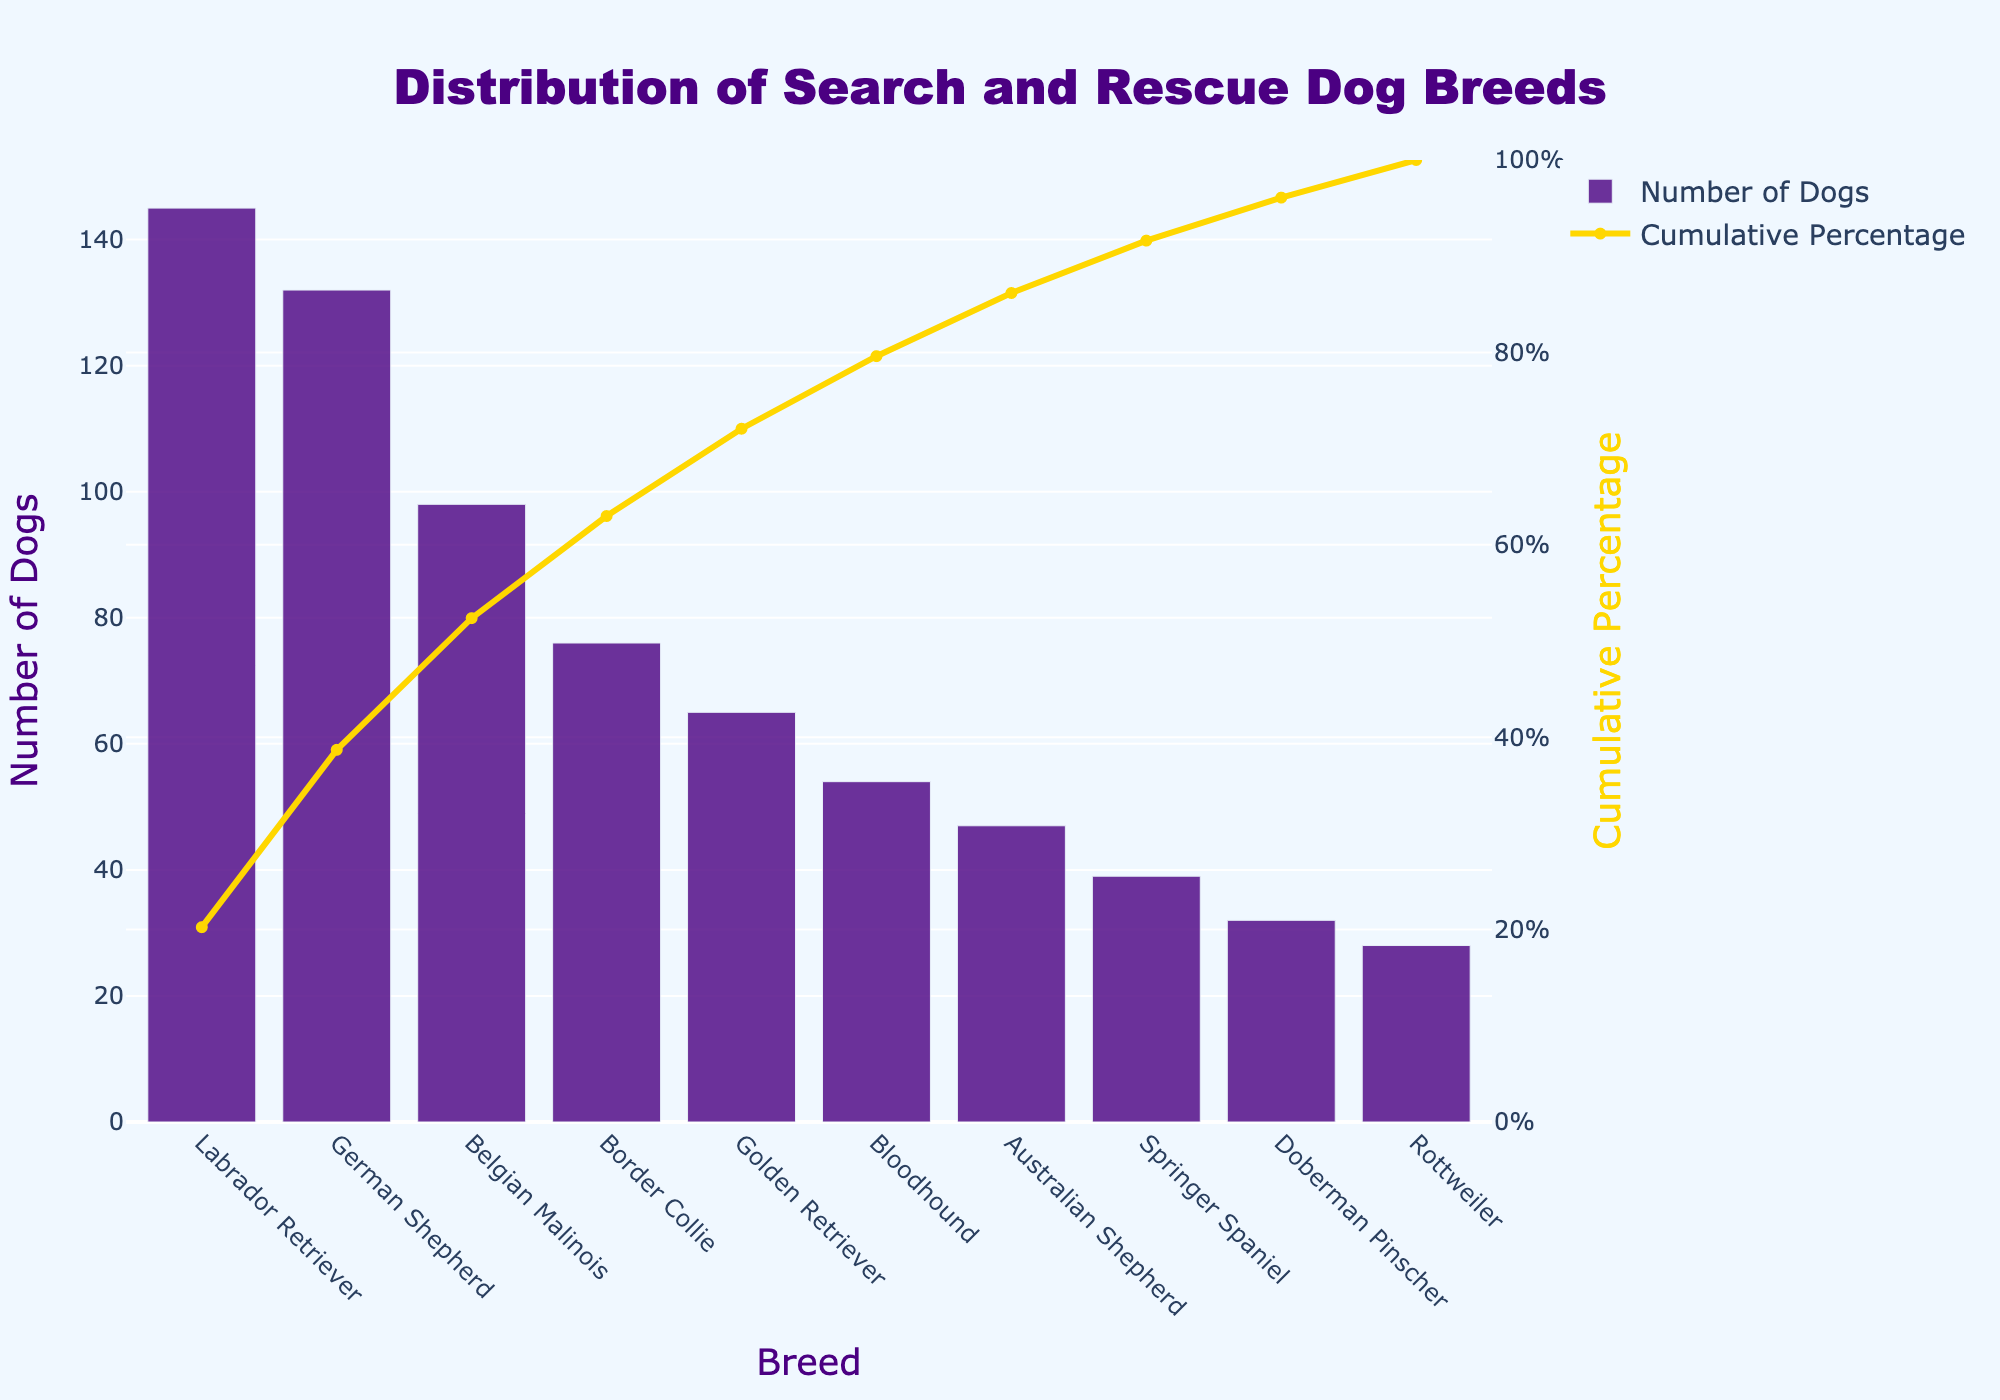What's the title of the chart? The title of the chart is typically located at the top and provides a brief description of the chart's content. Here, it is clearly stated at the top of the figure.
Answer: Distribution of Search and Rescue Dog Breeds How many breeds are displayed in the chart? To determine this, count the number of unique bars or categories on the x-axis. Each bar represents a different breed.
Answer: 10 Which breed has the highest number of search and rescue dogs? Look at the bar that is the tallest, which is indicative of the highest value on the y-axis.
Answer: Labrador Retriever What is the cumulative percentage for the German Shepherd breed? Locate the bar for German Shepherd and find its corresponding point on the cumulative percentage line, then extract the value from the y2-axis on the right.
Answer: Approximately 44% Name the top three breeds by the number of search and rescue dogs. Identify the first three bars from left to right, which correspond to the breeds with the highest values.
Answer: Labrador Retriever, German Shepherd, Belgian Malinois What percentage of the total search and rescue dogs does the top three breeds constitute? Sum the number of dogs for the top three breeds (145 + 132 + 98) to get 375. Divide this by the total number of dogs (716) and multiply by 100 to get the percentage. Total number of dogs can be calculated by summing all the given dogs numbers.
\[ (145 + 132 + 98) / 716 \times 100 = 52.37 \% \]
Answer: Approximately 52.37% How many dogs are there in breeds contributing to about 50% of the total number? To find this, continue summing the number of dogs from the largest until the cumulative percentage hits almost 50%. We find Labrador Retriever (145) + German Shepherd (132) and this achieves approximately 50%
Answer: 277 What's the number difference in search and rescue dogs between the most common breed and the least common breed? Subtract the number of dogs in the least common breed (Rottweiler) from the most common breed (Labrador Retriever). \( 145 - 28 = 117 \)
Answer: 117 Which breed's introduction increases the cumulative percentage closest to the 70% mark? By checking the cumulative percentage column, identify the breed where its addition makes the cumulative percentage just around 70%. This percentage can be observed at the Border Collie breed.
Answer: Border Collie 